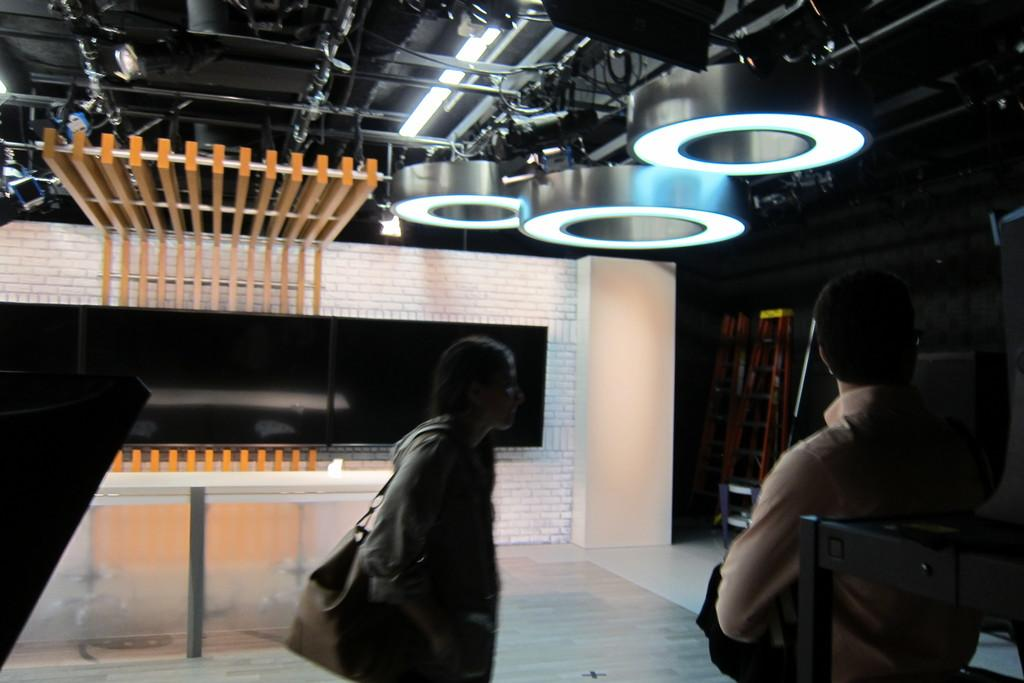How many people are in the image? There are two persons standing in the image. What are the persons facing or interacting with? There are televisions and other objects in front of the persons. What type of fruit is the zebra holding in the image? There is no zebra or fruit present in the image. 